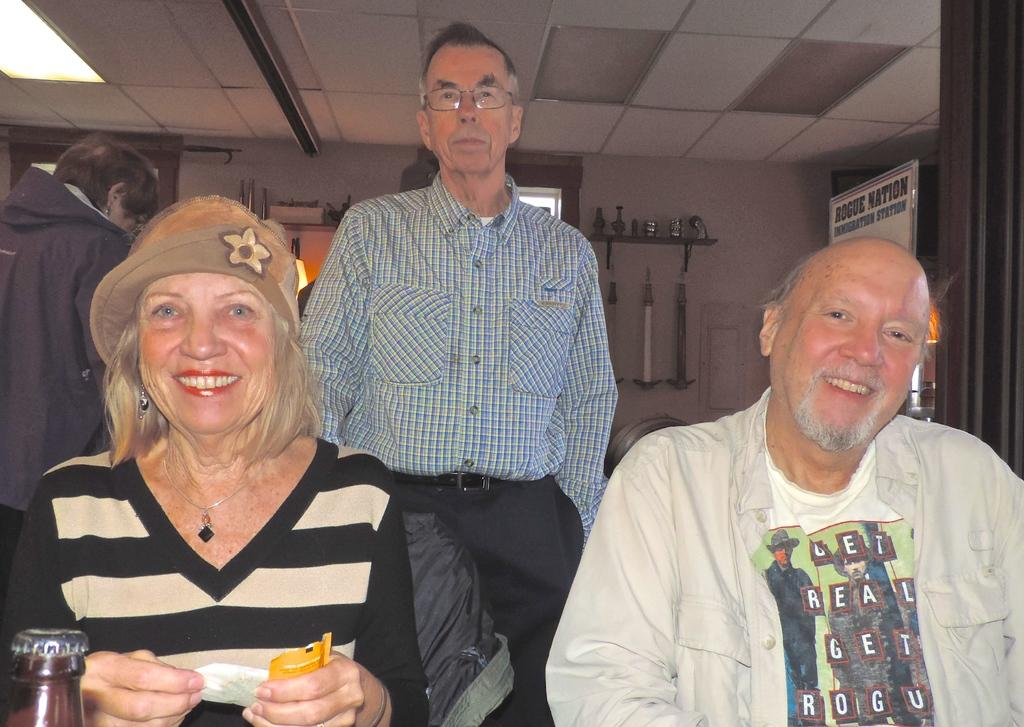<image>
Render a clear and concise summary of the photo. All smiles at the Rogue Nation get together! 